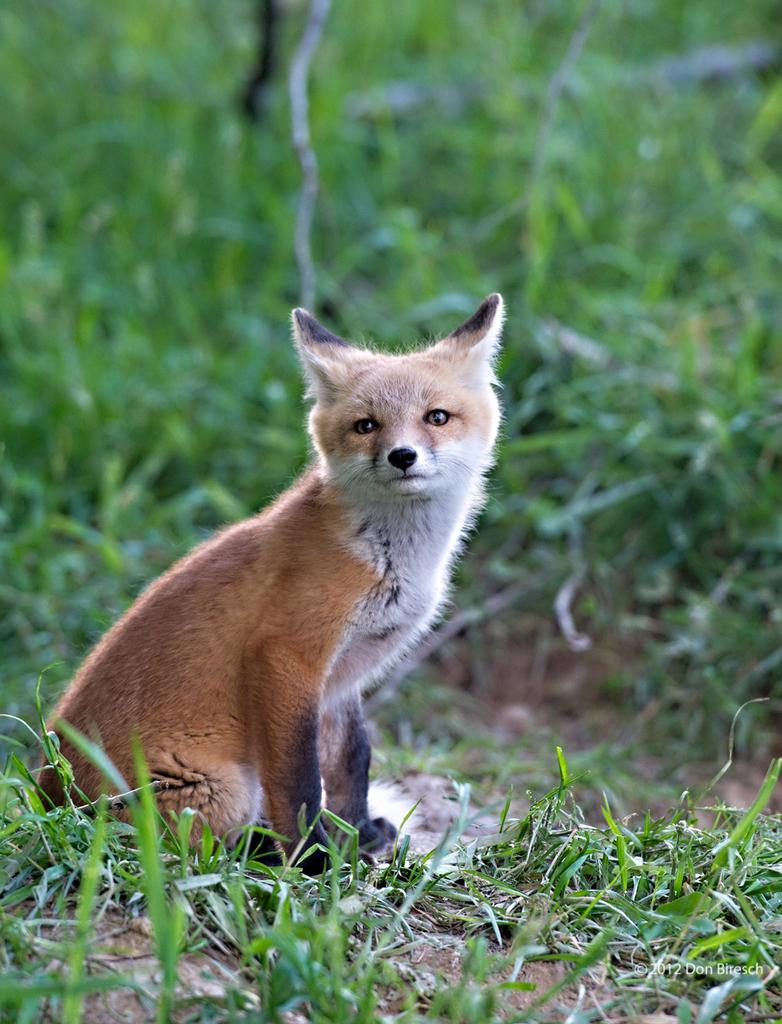What type of creature is in the image? There is an animal in the image. Can you describe the color pattern of the animal? The animal has brown and white colors. What can be seen in the background of the image? The background of the image includes green grass. How many sisters does the animal have in the image? There are no sisters mentioned or depicted in the image. What time does the clock show in the image? There is no clock present in the image. 